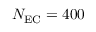Convert formula to latex. <formula><loc_0><loc_0><loc_500><loc_500>N _ { E C } = 4 0 0</formula> 